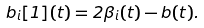<formula> <loc_0><loc_0><loc_500><loc_500>b _ { i } [ 1 ] ( t ) = 2 \beta _ { i } ( t ) - b ( t ) .</formula> 